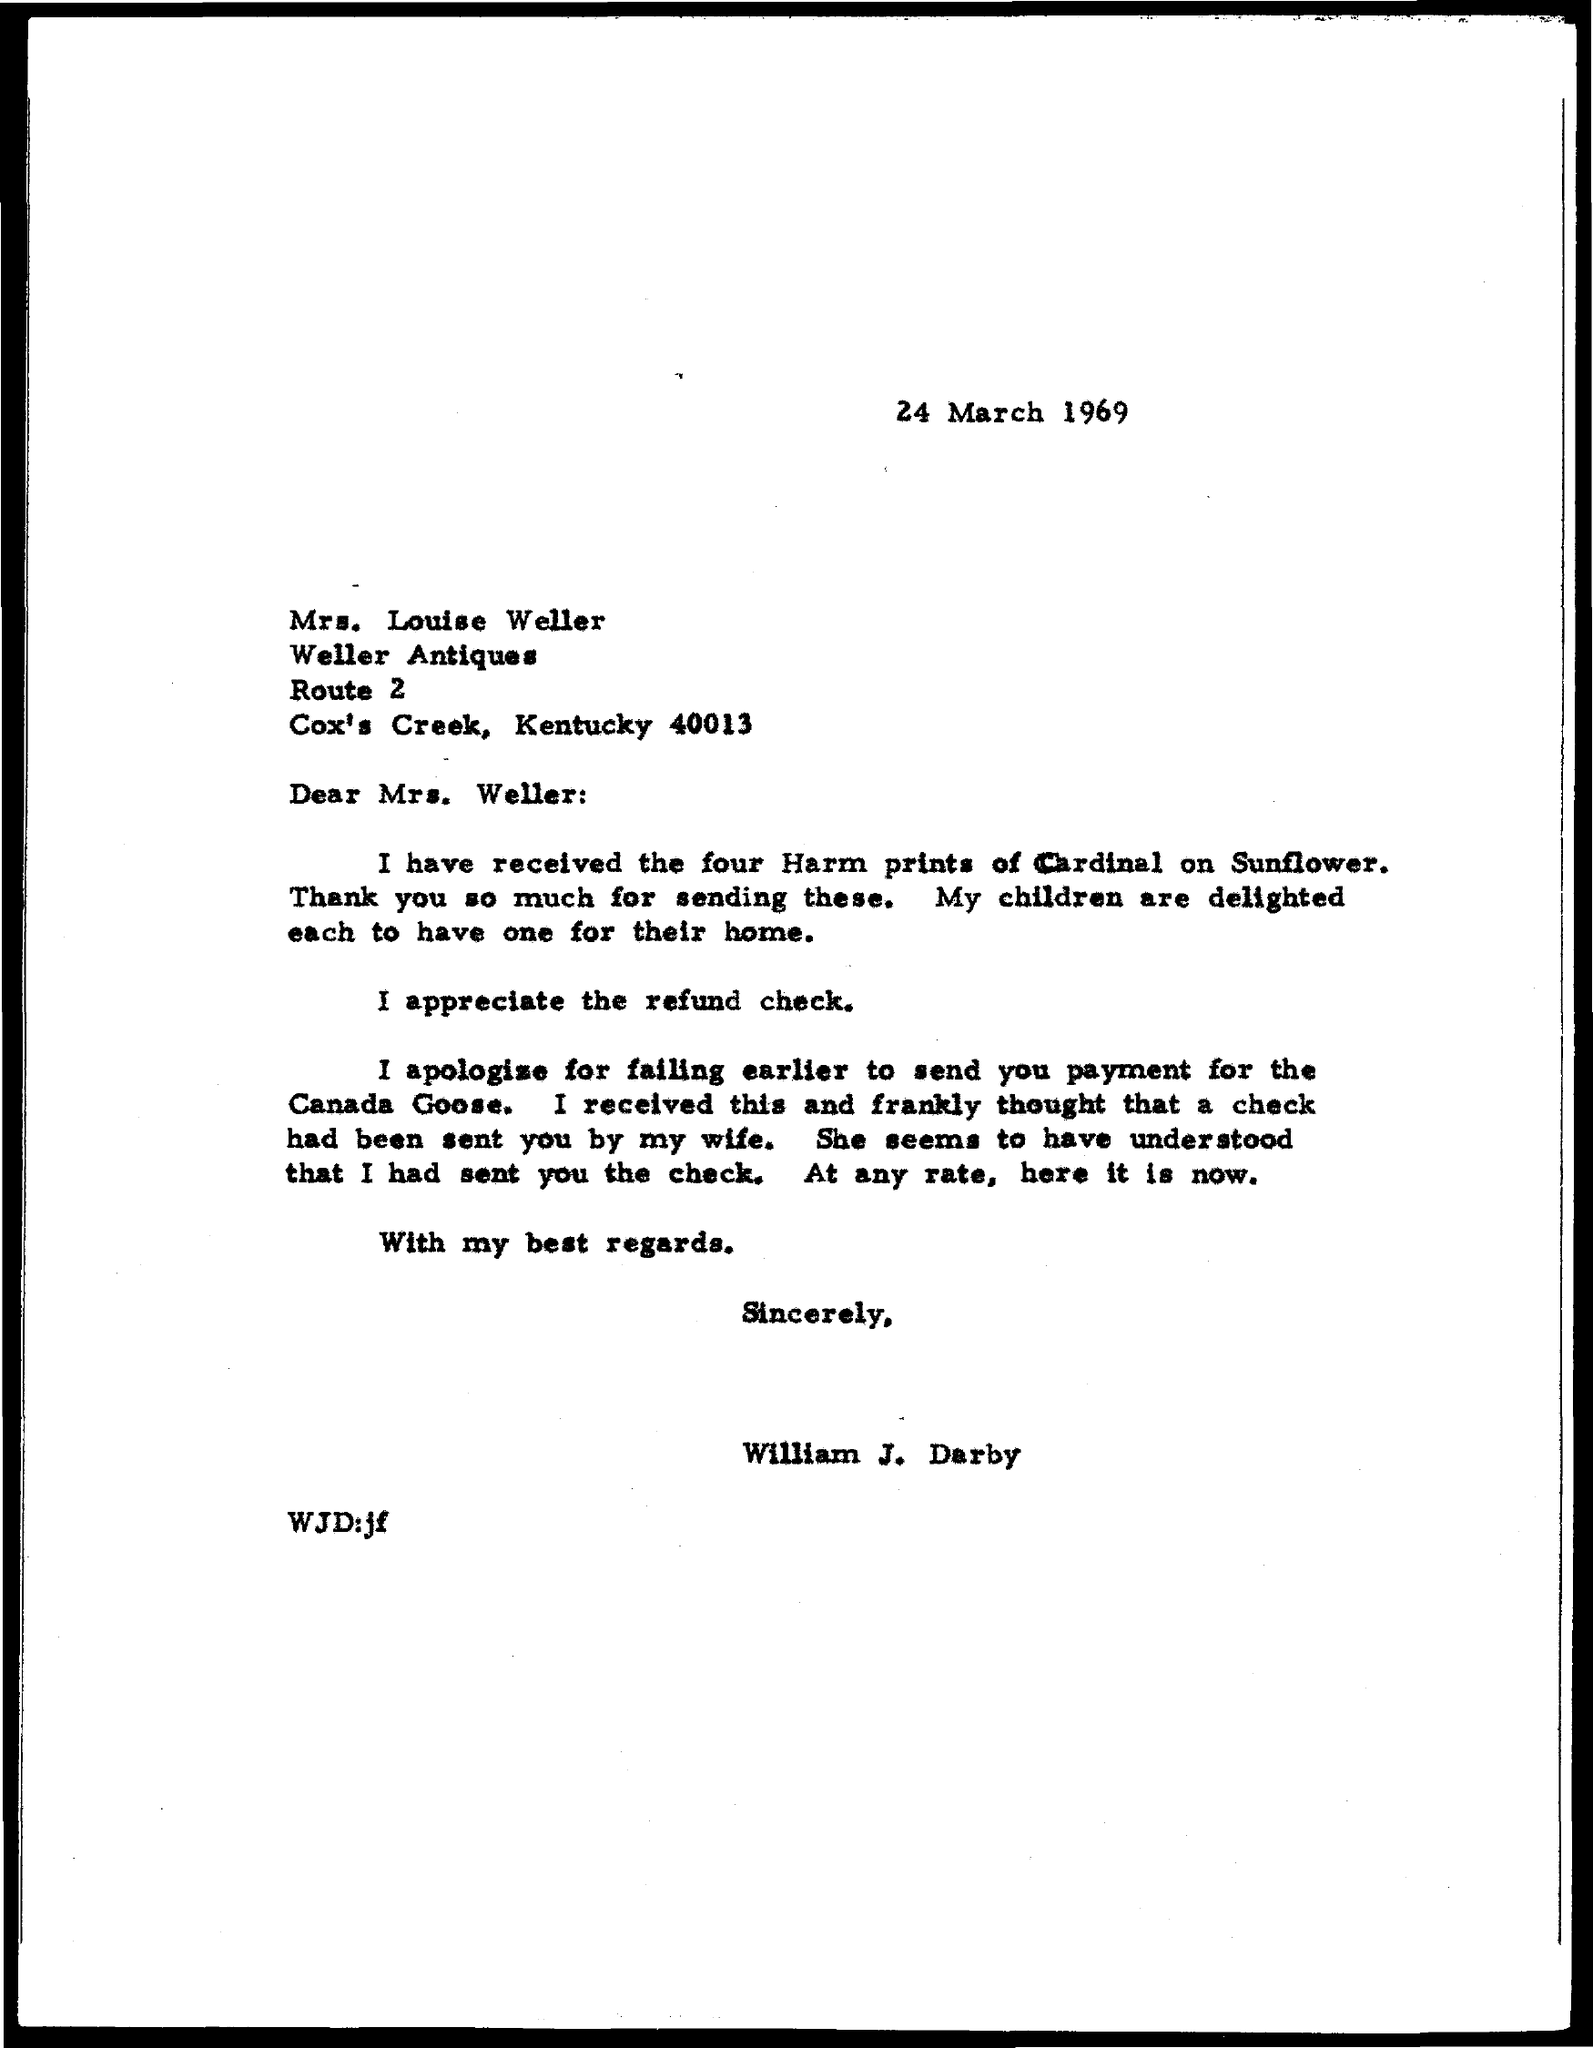Mention a couple of crucial points in this snapshot. The date mentioned is March 24, 1969. 